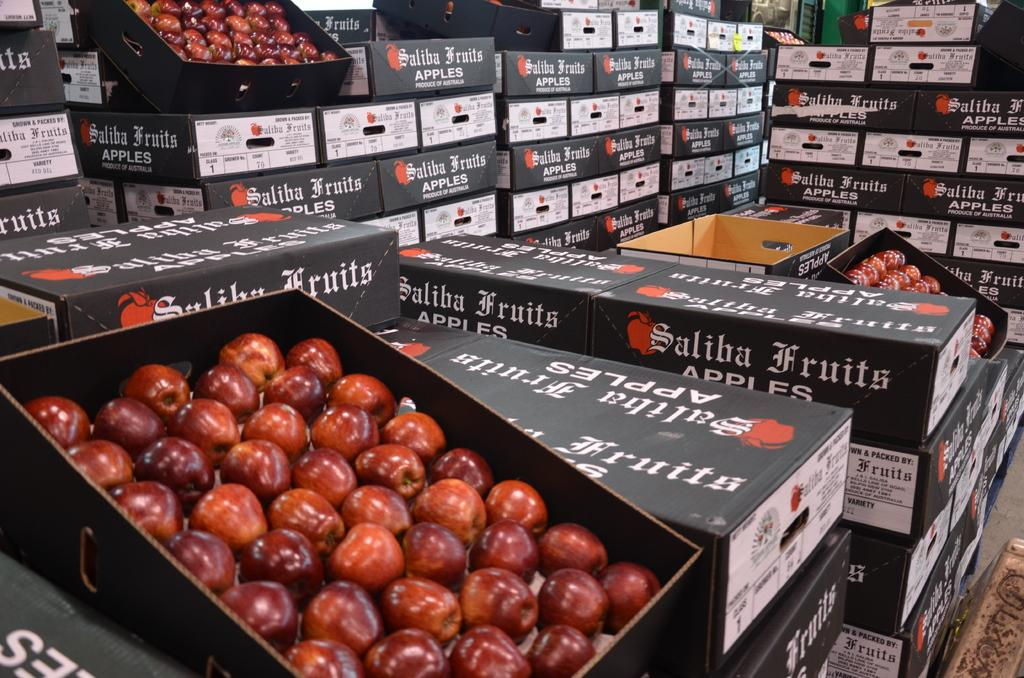What type of fruit is present in the image? There are apples in the image. What can be seen in the background of the image? There are boxes with text in the background of the image. How many wings can be seen on the apples in the image? There are no wings present on the apples in the image. 